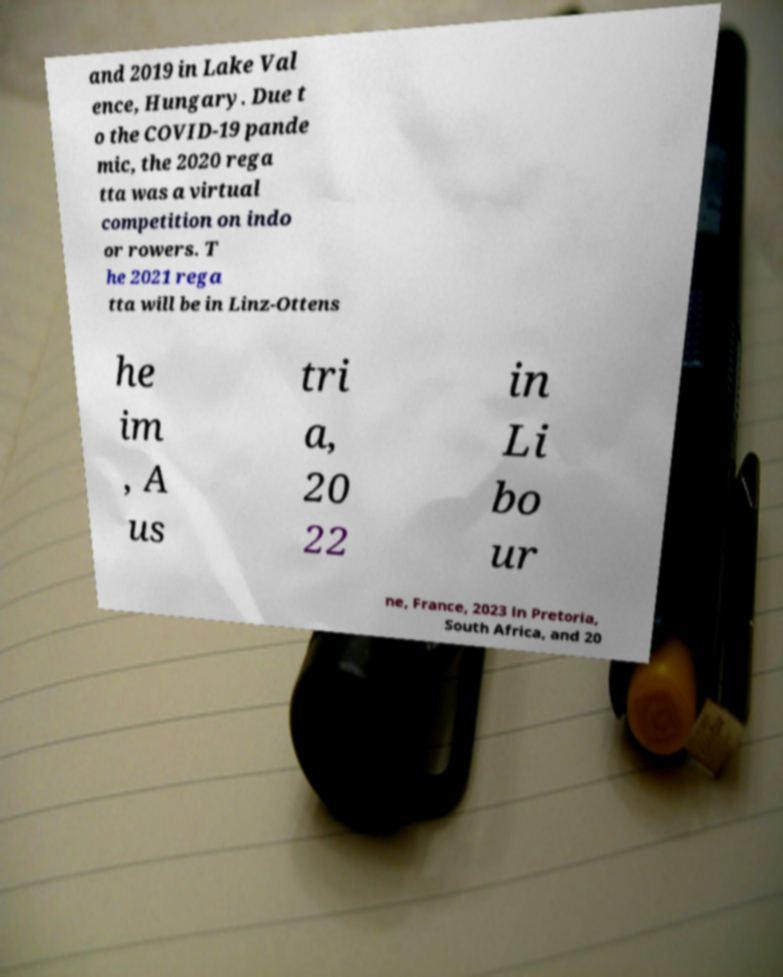What messages or text are displayed in this image? I need them in a readable, typed format. and 2019 in Lake Val ence, Hungary. Due t o the COVID-19 pande mic, the 2020 rega tta was a virtual competition on indo or rowers. T he 2021 rega tta will be in Linz-Ottens he im , A us tri a, 20 22 in Li bo ur ne, France, 2023 in Pretoria, South Africa, and 20 